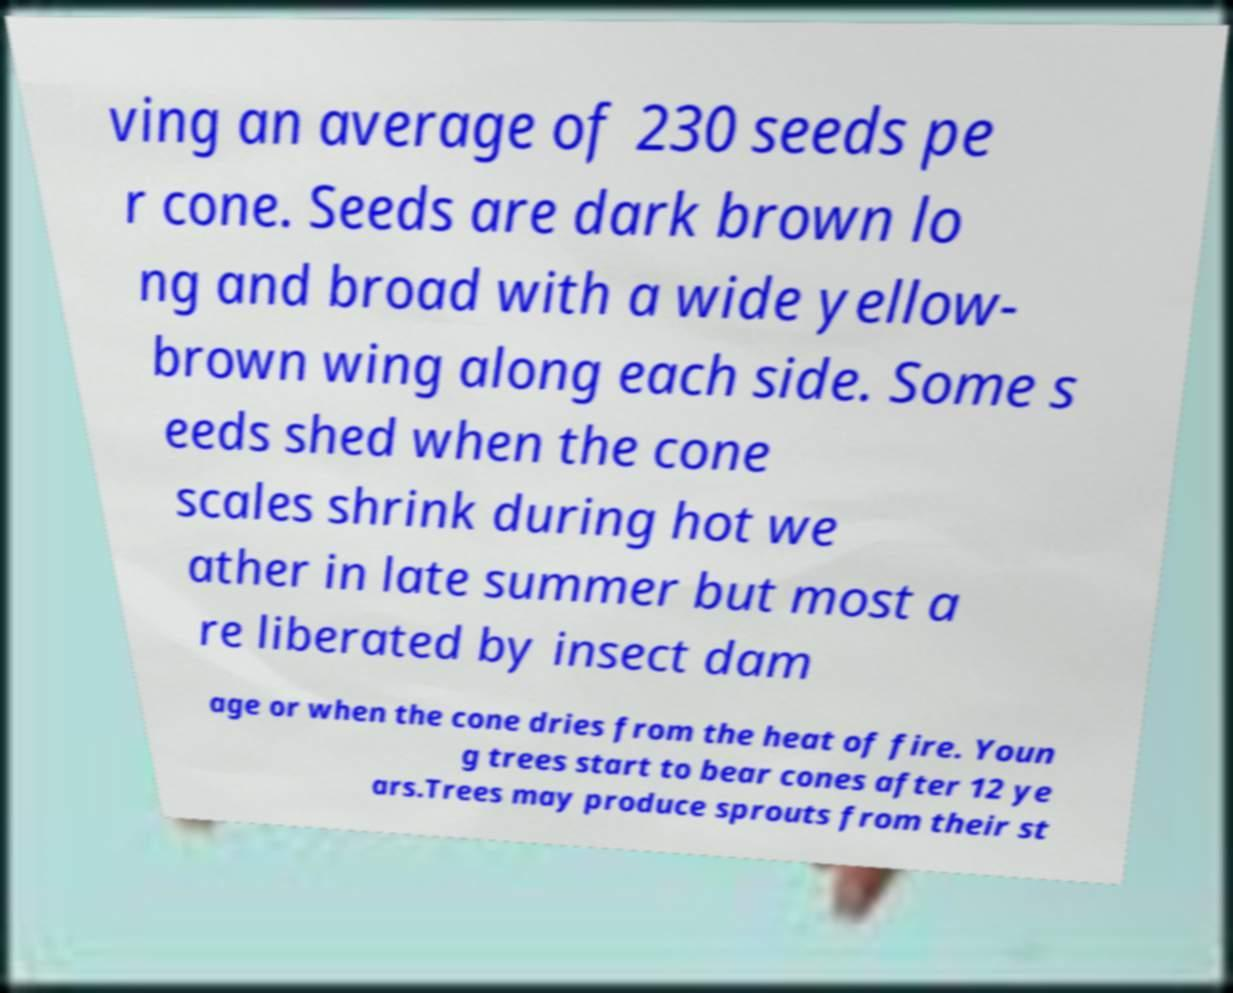There's text embedded in this image that I need extracted. Can you transcribe it verbatim? ving an average of 230 seeds pe r cone. Seeds are dark brown lo ng and broad with a wide yellow- brown wing along each side. Some s eeds shed when the cone scales shrink during hot we ather in late summer but most a re liberated by insect dam age or when the cone dries from the heat of fire. Youn g trees start to bear cones after 12 ye ars.Trees may produce sprouts from their st 